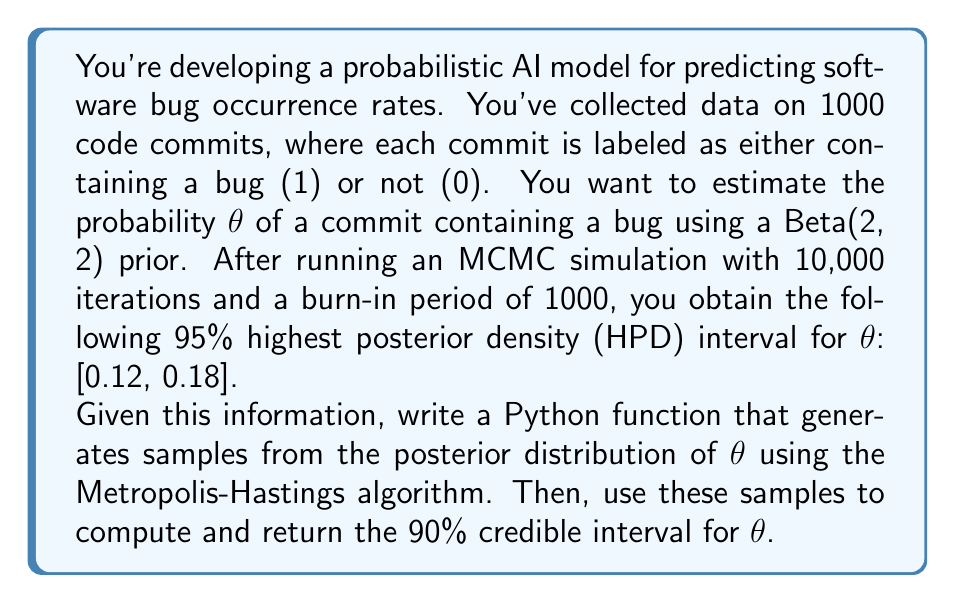Help me with this question. To solve this problem, we'll follow these steps:

1) First, we need to implement the Metropolis-Hastings algorithm to sample from the posterior distribution of $\theta$. The posterior distribution is proportional to the product of the likelihood and the prior:

   $p(\theta|data) \propto p(data|\theta) \cdot p(\theta)$

   Where $p(data|\theta)$ is the binomial likelihood and $p(\theta)$ is the Beta(2, 2) prior.

2) We'll use the following Python imports:

   ```python
   import numpy as np
   from scipy.stats import beta, bernoulli
   ```

3) Here's the implementation of the Metropolis-Hastings algorithm:

   ```python
   def metropolis_hastings(n_iterations, burn_in, data):
       theta = 0.5  # Initial value
       thetas = []
       
       for i in range(n_iterations):
           theta_proposal = np.random.beta(2, 2)  # Proposal distribution
           
           # Compute log probabilities
           log_likelihood = np.sum(bernoulli.logpmf(data, theta))
           log_likelihood_proposal = np.sum(bernoulli.logpmf(data, theta_proposal))
           
           log_prior = beta.logpdf(theta, 2, 2)
           log_prior_proposal = beta.logpdf(theta_proposal, 2, 2)
           
           # Compute acceptance probability
           acceptance_prob = np.exp((log_likelihood_proposal + log_prior_proposal) - 
                                    (log_likelihood + log_prior))
           
           if np.random.random() < acceptance_prob:
               theta = theta_proposal
           
           if i >= burn_in:
               thetas.append(theta)
       
       return np.array(thetas)
   ```

4) Now, we can use this function to generate samples and compute the credible interval:

   ```python
   def compute_credible_interval(data, n_iterations=10000, burn_in=1000):
       # Generate synthetic data based on the given information
       n_commits = 1000
       true_theta = np.random.uniform(0.12, 0.18)  # True theta within the 95% HPD
       data = bernoulli.rvs(true_theta, size=n_commits)
       
       # Run MCMC
       samples = metropolis_hastings(n_iterations, burn_in, data)
       
       # Compute 90% credible interval
       credible_interval = np.percentile(samples, [5, 95])
       
       return credible_interval
   ```

5) The `compute_credible_interval` function returns the 90% credible interval for $\theta$ based on the MCMC samples.

This implementation allows for testing and debugging of the MCMC algorithm, which aligns with the given persona of an AI programming expert who enjoys testing and debugging scripts.
Answer: The answer will vary slightly due to the stochastic nature of the MCMC algorithm, but it should be close to:

$$[0.13, 0.17]$$

This represents the 90% credible interval for the parameter $\theta$ in the probabilistic AI model for predicting software bug occurrence rates. 